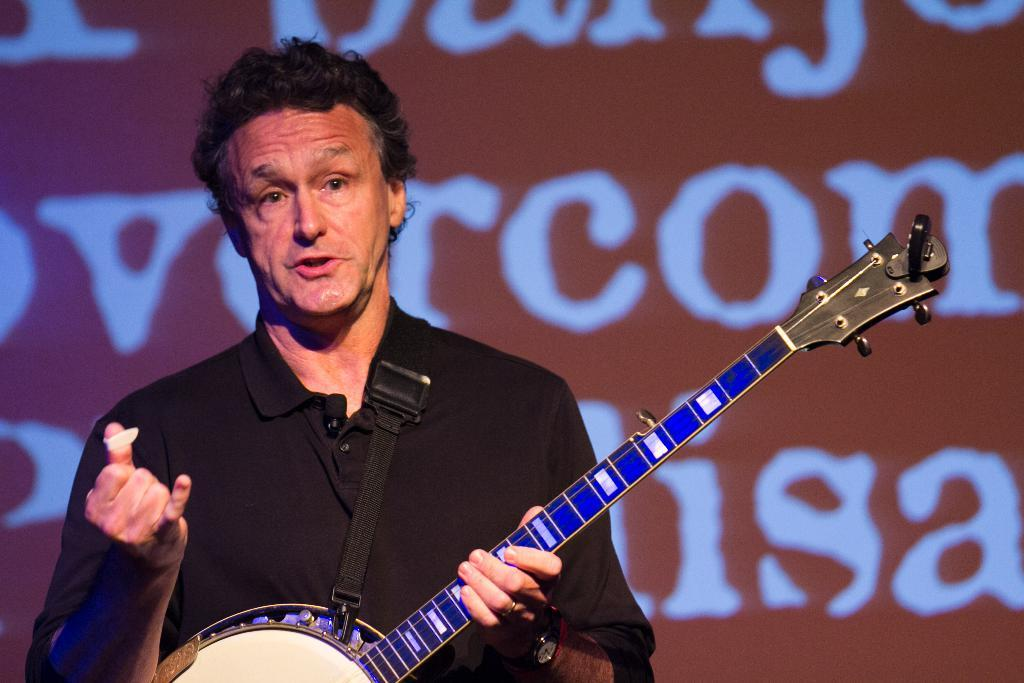Who is present in the image? There is a man in the image. What is the man doing in the image? The man is standing in the image. What is the man holding in the image? The man is holding a musical instrument in the image. What can be seen in the background of the image? There is a board in the background of the image. How many apples are on the fan in the image? There are no apples or fans present in the image. 